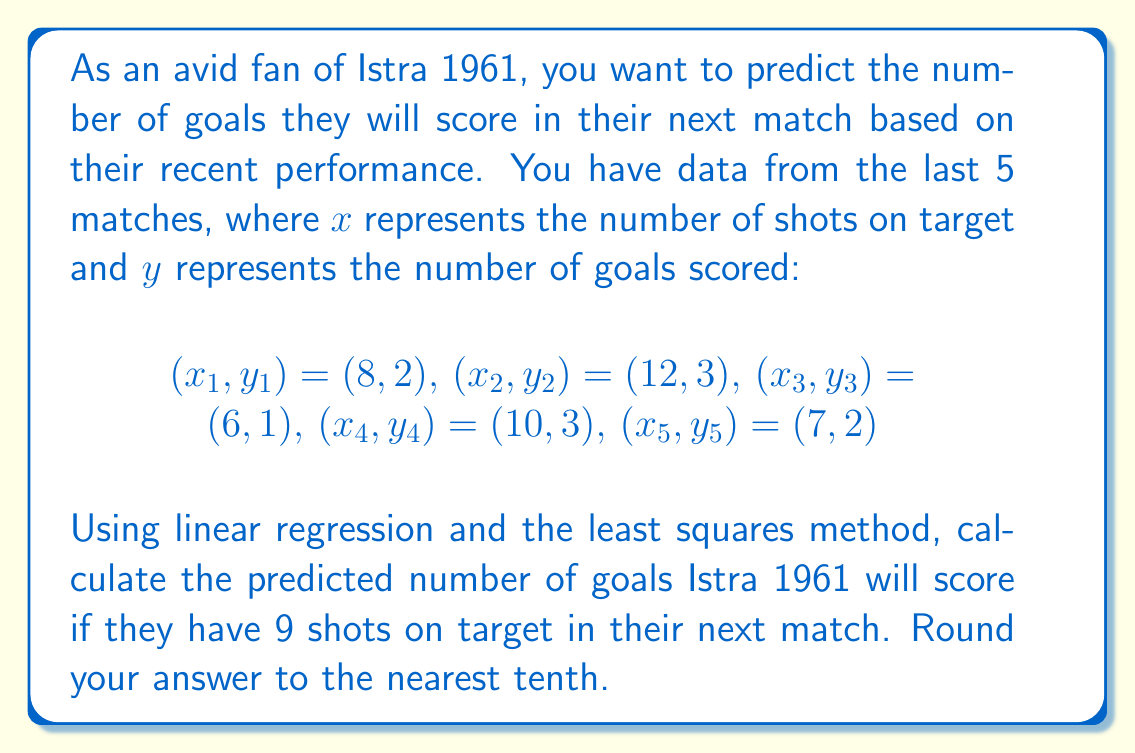Could you help me with this problem? To solve this problem, we'll use linear regression with the least squares method. We'll follow these steps:

1) First, we need to calculate the following sums:
   $$\sum x_i, \sum y_i, \sum x_i^2, \sum x_iy_i$$

   $\sum x_i = 8 + 12 + 6 + 10 + 7 = 43$
   $\sum y_i = 2 + 3 + 1 + 3 + 2 = 11$
   $\sum x_i^2 = 8^2 + 12^2 + 6^2 + 10^2 + 7^2 = 379$
   $\sum x_iy_i = 8(2) + 12(3) + 6(1) + 10(3) + 7(2) = 101$

2) Now, we can use these sums to calculate the slope (m) and y-intercept (b) of our regression line:

   $$m = \frac{n\sum x_iy_i - \sum x_i \sum y_i}{n\sum x_i^2 - (\sum x_i)^2}$$

   $$b = \frac{\sum y_i - m\sum x_i}{n}$$

   Where n is the number of data points (5 in this case).

3) Let's calculate m:

   $$m = \frac{5(101) - 43(11)}{5(379) - 43^2} = \frac{505 - 473}{1895 - 1849} = \frac{32}{46} = 0.6957$$

4) Now, let's calculate b:

   $$b = \frac{11 - 0.6957(43)}{5} = \frac{11 - 29.9151}{5} = -3.7830$$

5) Our regression line equation is:

   $$y = 0.6957x - 3.7830$$

6) To predict the number of goals for 9 shots on target, we substitute x = 9:

   $$y = 0.6957(9) - 3.7830 = 6.2613 - 3.7830 = 2.4783$$

7) Rounding to the nearest tenth:

   $$2.4783 \approx 2.5$$
Answer: 2.5 goals 